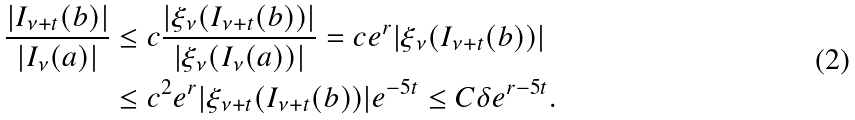Convert formula to latex. <formula><loc_0><loc_0><loc_500><loc_500>\frac { | I _ { \nu + t } ( b ) | } { | I _ { \nu } ( a ) | } & \leq c \frac { | \xi _ { \nu } ( I _ { \nu + t } ( b ) ) | } { | \xi _ { \nu } ( I _ { \nu } ( a ) ) | } = c e ^ { r } | \xi _ { \nu } ( I _ { \nu + t } ( b ) ) | \\ & \leq c ^ { 2 } e ^ { r } | \xi _ { \nu + t } ( I _ { \nu + t } ( b ) ) | e ^ { - 5 t } \leq C \delta e ^ { r - 5 t } .</formula> 